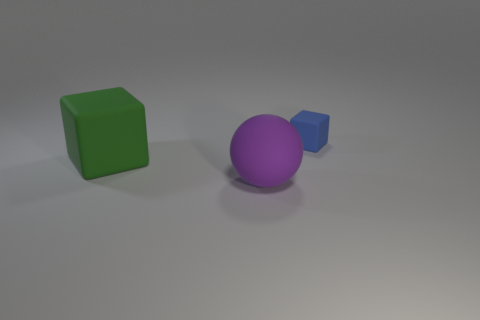Add 3 large yellow matte balls. How many objects exist? 6 Subtract all cubes. How many objects are left? 1 Subtract all small cubes. Subtract all big spheres. How many objects are left? 1 Add 1 large matte blocks. How many large matte blocks are left? 2 Add 3 large rubber spheres. How many large rubber spheres exist? 4 Subtract 0 purple cylinders. How many objects are left? 3 